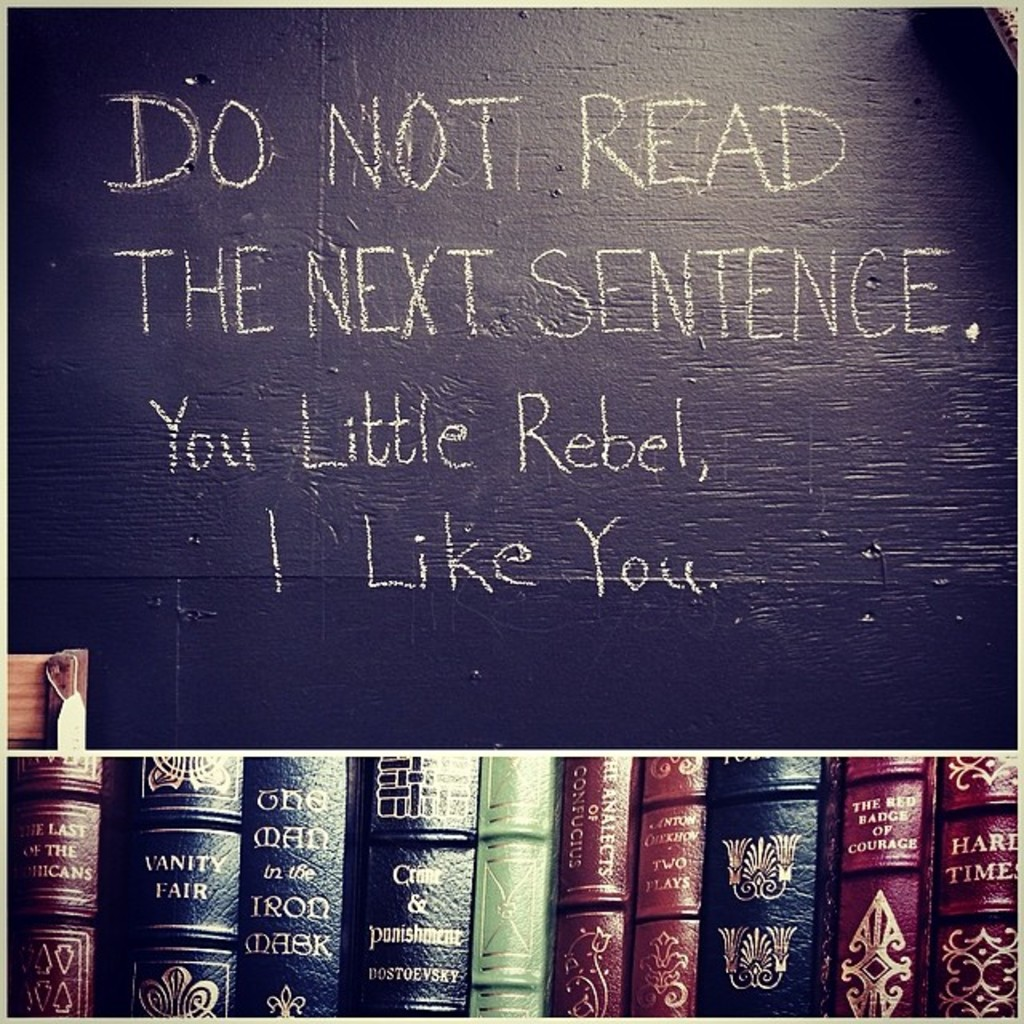What do you see happening in this image? The image features a creatively written statement on a blackboard that humorously plays with the reader's curiosity. The statement starts with 'Do not read the next sentence,' immediately followed by 'You little rebel, I like you,' celebrating the reader's defiance humorously. Below the blackboard, a neatly arranged shelf holds an array of classic literature, including 'Vanity Fair' and 'The Count of Monte Cristo.' This juxtaposition of wit and literature suggests a setting that values humor, perhaps in an educational or personal space where creativity is encouraged. The use of dark tones and text in white chalk adds a striking visual contrast, enhancing the playful message. 